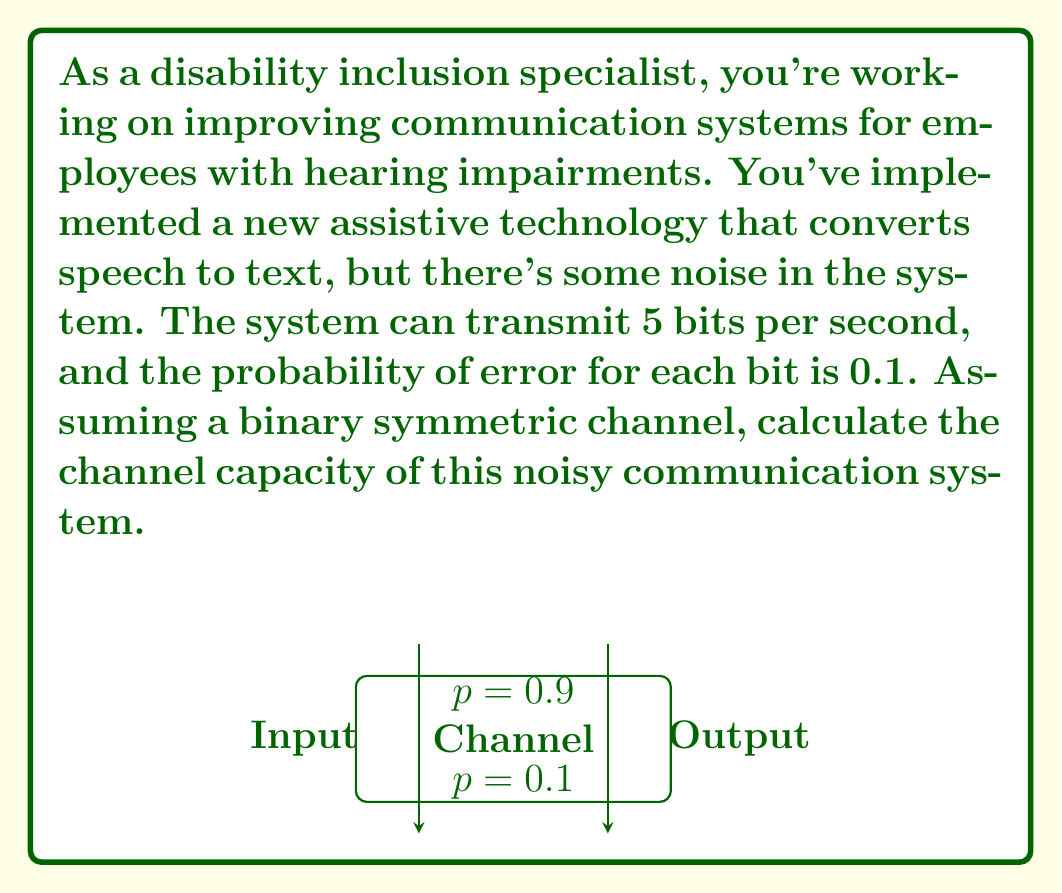Provide a solution to this math problem. To solve this problem, we'll use the channel capacity formula for a binary symmetric channel:

$$ C = R(1 - H(p)) $$

Where:
- $C$ is the channel capacity in bits per second
- $R$ is the raw bit rate of the channel (5 bits per second in this case)
- $H(p)$ is the binary entropy function
- $p$ is the probability of error (0.1 in this case)

Steps:
1) First, we need to calculate $H(p)$:
   $$ H(p) = -p \log_2(p) - (1-p) \log_2(1-p) $$
   $$ H(0.1) = -0.1 \log_2(0.1) - 0.9 \log_2(0.9) $$
   $$ H(0.1) \approx 0.469 $$

2) Now we can plug this into our channel capacity formula:
   $$ C = 5(1 - 0.469) $$
   $$ C = 5(0.531) $$
   $$ C \approx 2.655 \text{ bits per second} $$

Therefore, the channel capacity of this noisy communication system is approximately 2.655 bits per second.
Answer: $2.655 \text{ bits/s}$ 